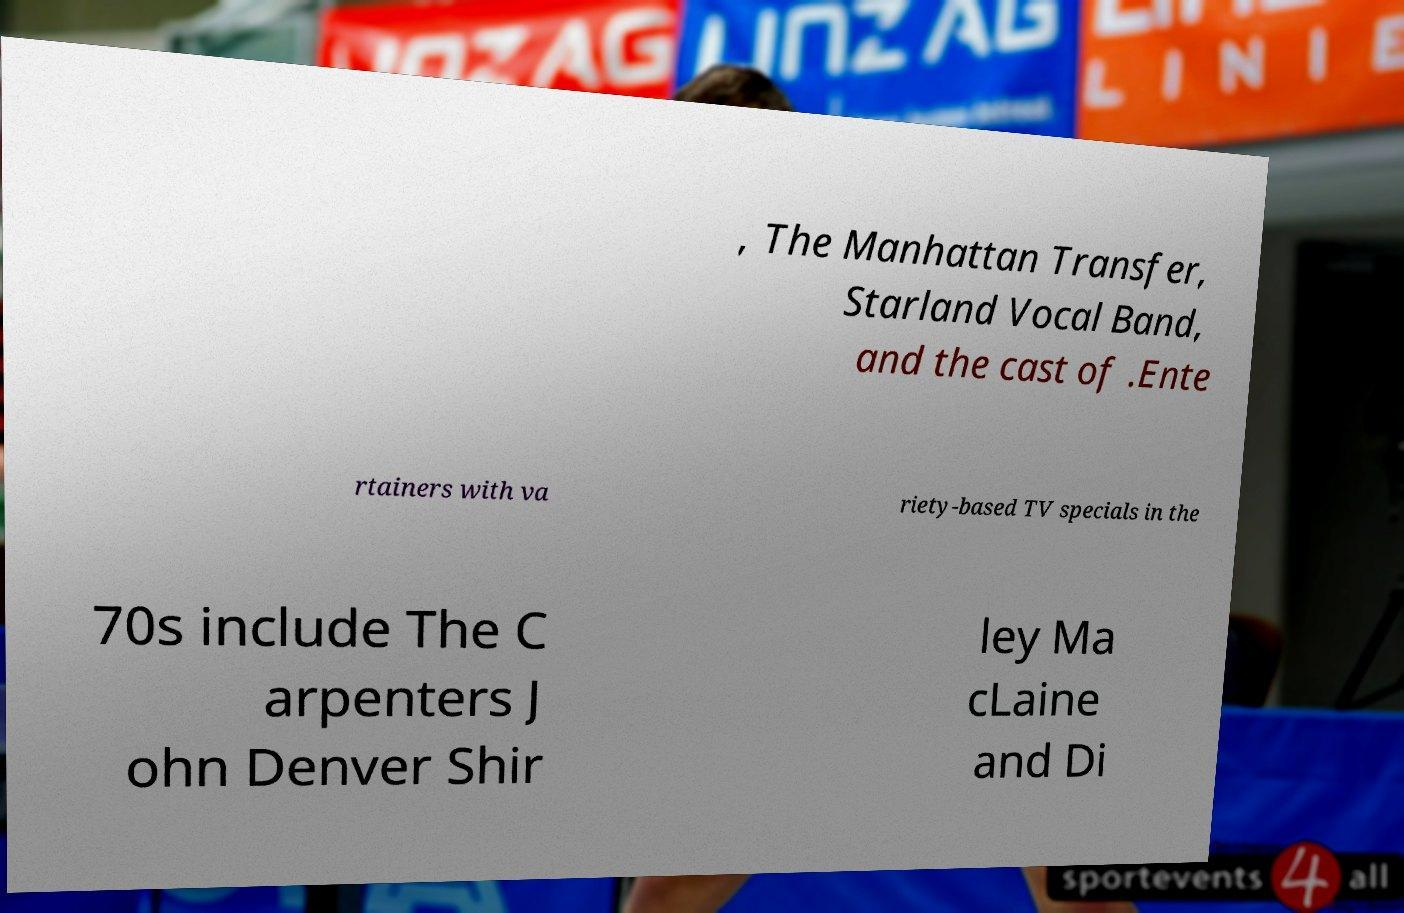Could you extract and type out the text from this image? , The Manhattan Transfer, Starland Vocal Band, and the cast of .Ente rtainers with va riety-based TV specials in the 70s include The C arpenters J ohn Denver Shir ley Ma cLaine and Di 